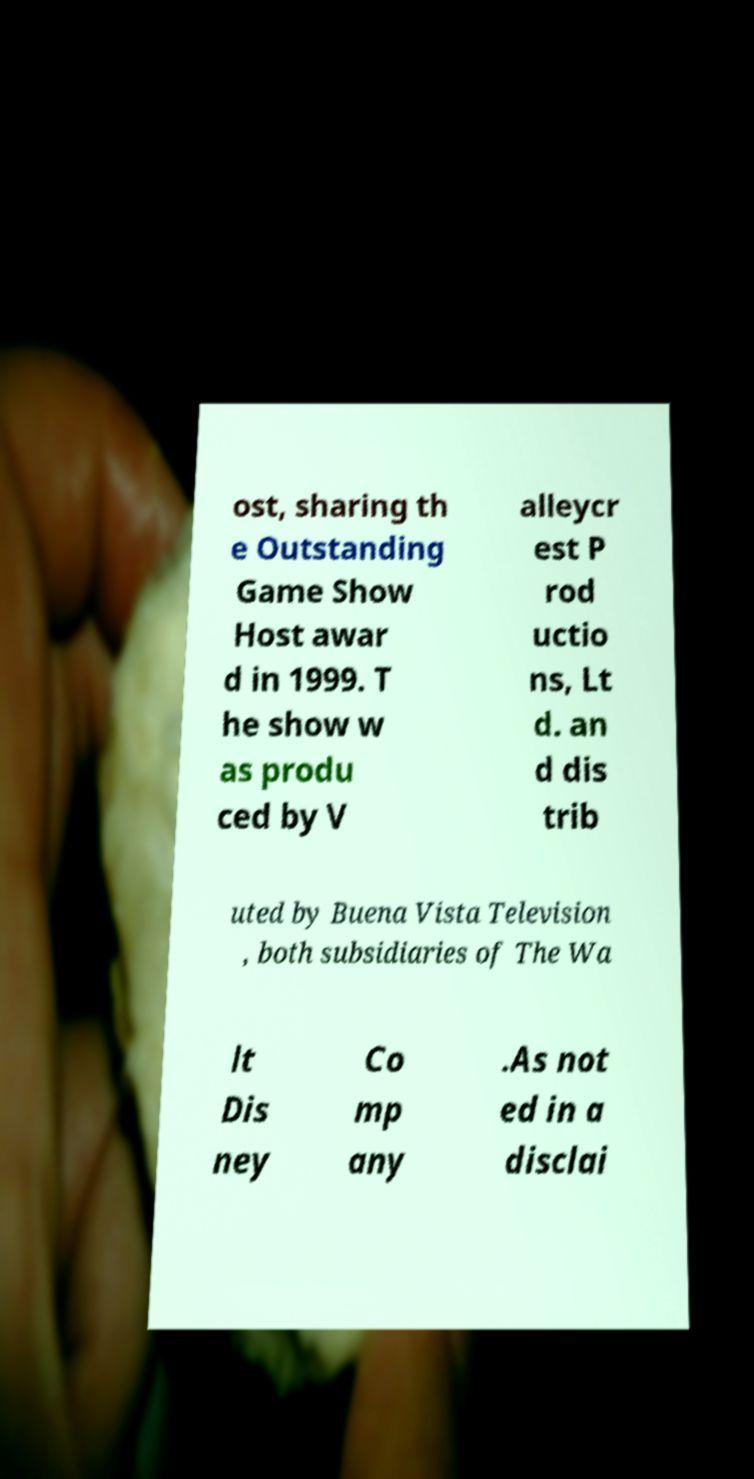What messages or text are displayed in this image? I need them in a readable, typed format. ost, sharing th e Outstanding Game Show Host awar d in 1999. T he show w as produ ced by V alleycr est P rod uctio ns, Lt d. an d dis trib uted by Buena Vista Television , both subsidiaries of The Wa lt Dis ney Co mp any .As not ed in a disclai 